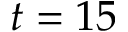<formula> <loc_0><loc_0><loc_500><loc_500>t = 1 5</formula> 